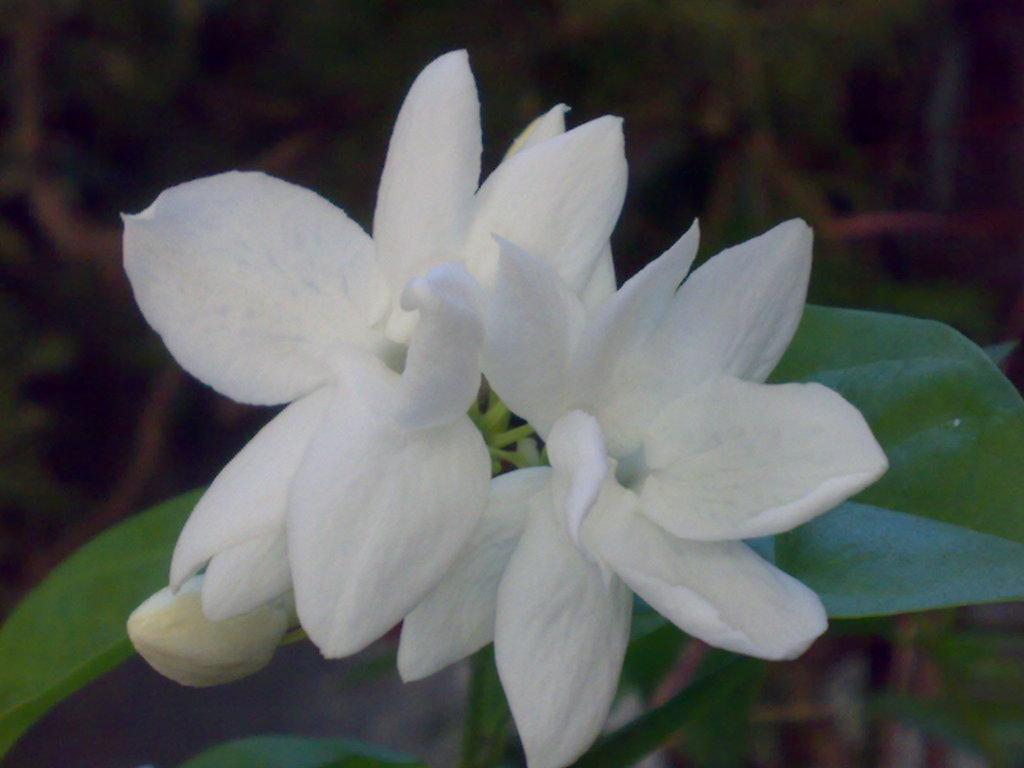What type of plants can be seen in the image? There are flowers and leaves in the image. Can you describe the background of the image? The background of the image is blurry. How many girls are smiling in the image? There are no girls present in the image, so it is not possible to determine how many are smiling. 